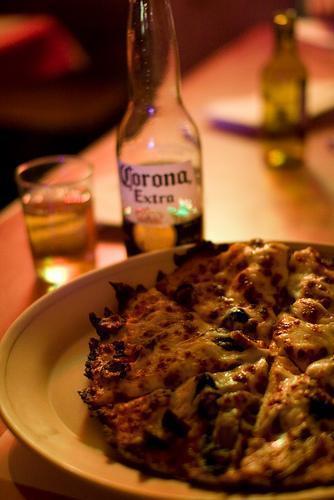How many slices of pizza are in the picture?
Give a very brief answer. 6. 